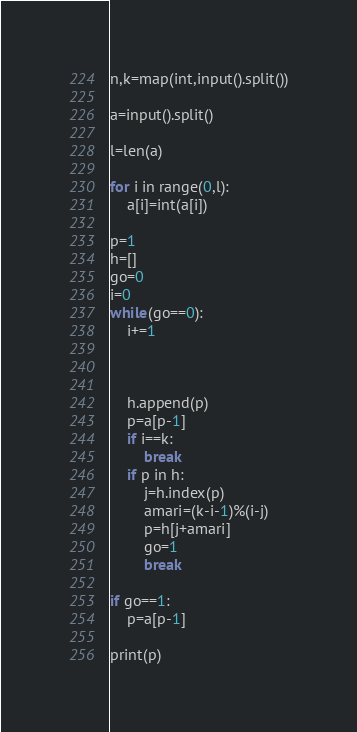Convert code to text. <code><loc_0><loc_0><loc_500><loc_500><_Python_>n,k=map(int,input().split())

a=input().split()

l=len(a)

for i in range(0,l):
    a[i]=int(a[i])

p=1
h=[]
go=0
i=0
while(go==0):
    i+=1
    
    

    h.append(p)
    p=a[p-1]
    if i==k:
        break
    if p in h:
        j=h.index(p)
        amari=(k-i-1)%(i-j)
        p=h[j+amari]
        go=1
        break

if go==1:
    p=a[p-1]

print(p)
</code> 